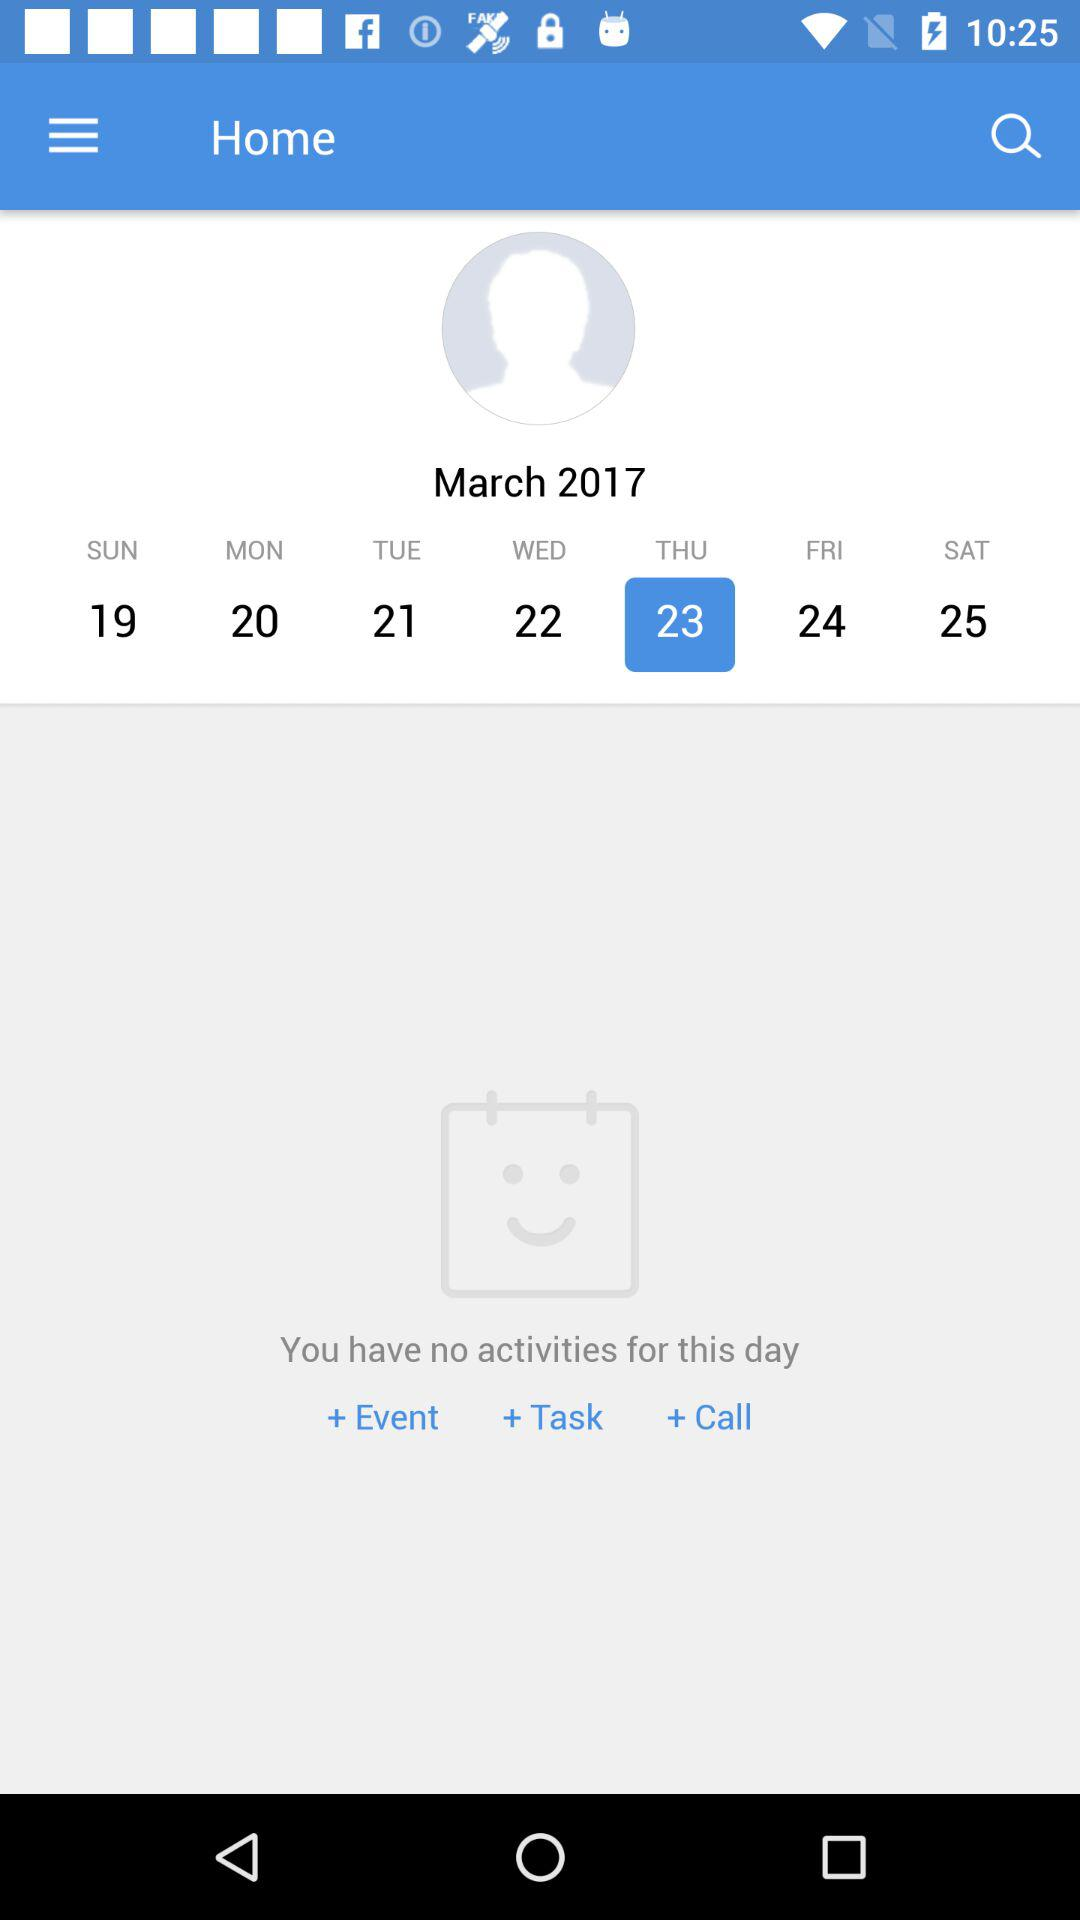What is the name of the application?
When the provided information is insufficient, respond with <no answer>. <no answer> 